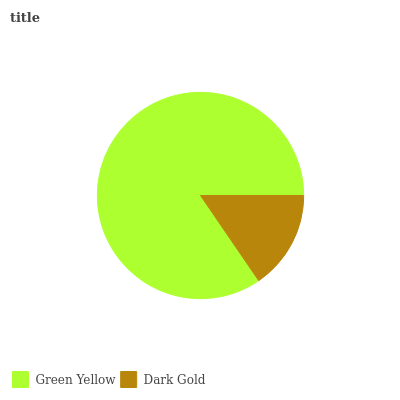Is Dark Gold the minimum?
Answer yes or no. Yes. Is Green Yellow the maximum?
Answer yes or no. Yes. Is Dark Gold the maximum?
Answer yes or no. No. Is Green Yellow greater than Dark Gold?
Answer yes or no. Yes. Is Dark Gold less than Green Yellow?
Answer yes or no. Yes. Is Dark Gold greater than Green Yellow?
Answer yes or no. No. Is Green Yellow less than Dark Gold?
Answer yes or no. No. Is Green Yellow the high median?
Answer yes or no. Yes. Is Dark Gold the low median?
Answer yes or no. Yes. Is Dark Gold the high median?
Answer yes or no. No. Is Green Yellow the low median?
Answer yes or no. No. 